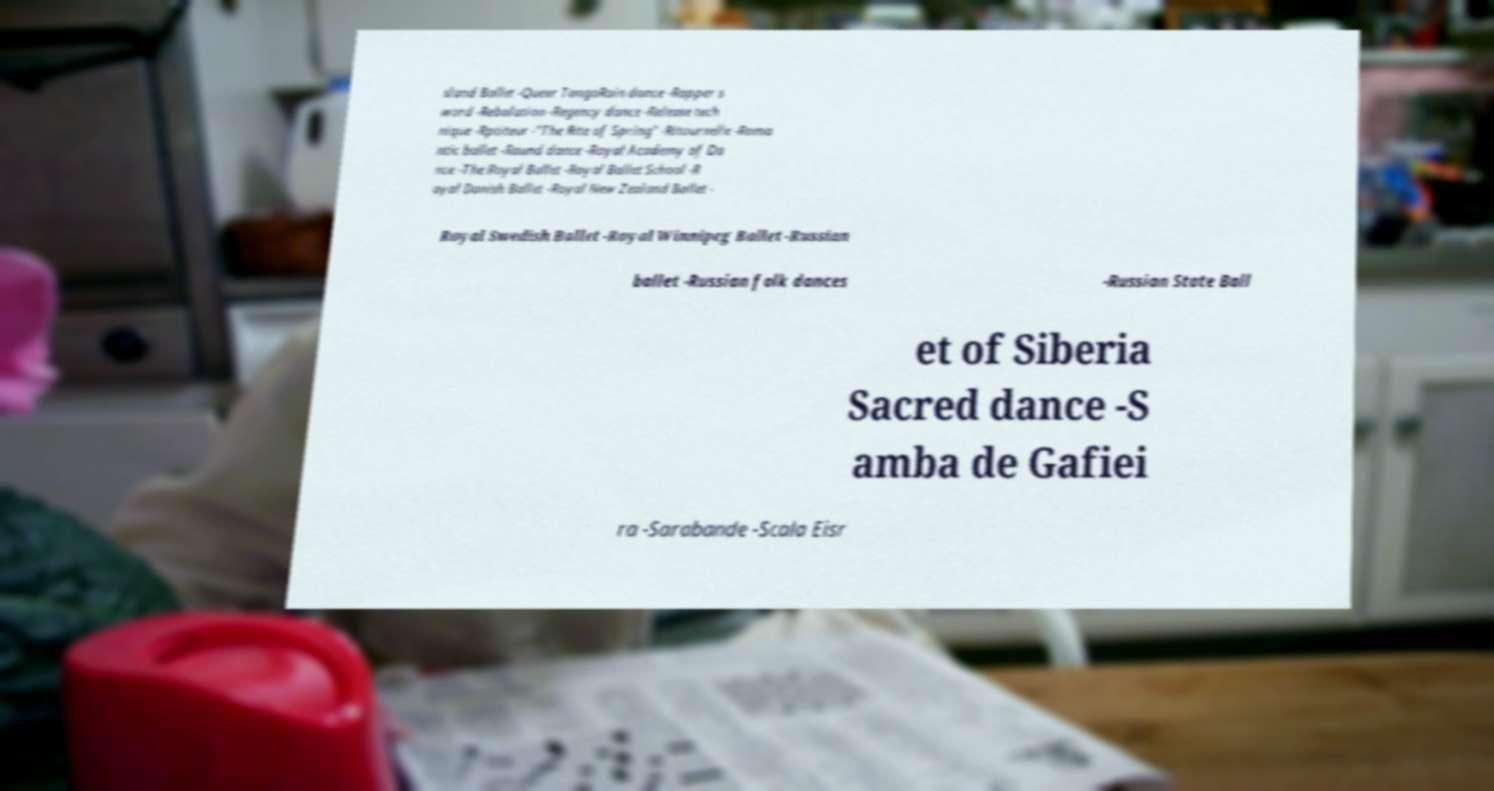Could you extract and type out the text from this image? sland Ballet -Queer TangoRain dance -Rapper s word -Rebolation -Regency dance -Release tech nique -Rptiteur -"The Rite of Spring" -Ritournelle -Roma ntic ballet -Round dance -Royal Academy of Da nce -The Royal Ballet -Royal Ballet School -R oyal Danish Ballet -Royal New Zealand Ballet - Royal Swedish Ballet -Royal Winnipeg Ballet -Russian ballet -Russian folk dances -Russian State Ball et of Siberia Sacred dance -S amba de Gafiei ra -Sarabande -Scala Eisr 